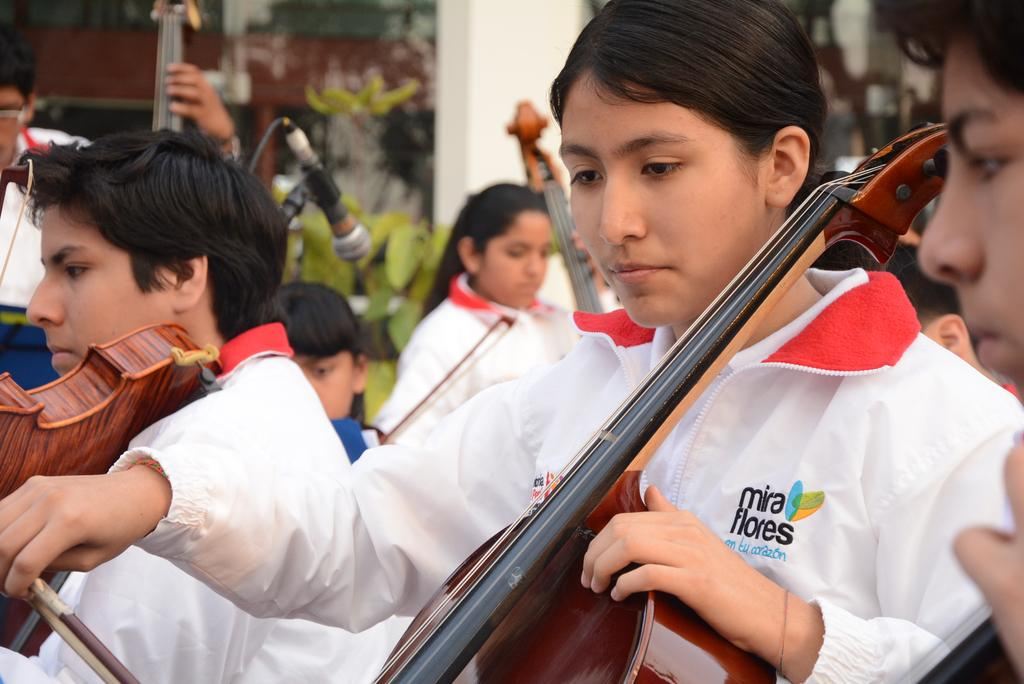How many persons are in the image? There are persons in the image. What are the persons doing in the image? The persons are playing the violin. How are the persons playing the violin? The violin is being played by catching it with their hands. What is present in the image to amplify sound? There is a microphone in the image. What type of natural environment is visible in the image? There are trees near the persons. What type of fuel is being used to power the violin in the image? There is no fuel being used to power the violin in the image; it is played by catching it with their hands. What color is the paint on the trees in the image? There is no mention of paint on the trees in the image; they are simply described as trees. 